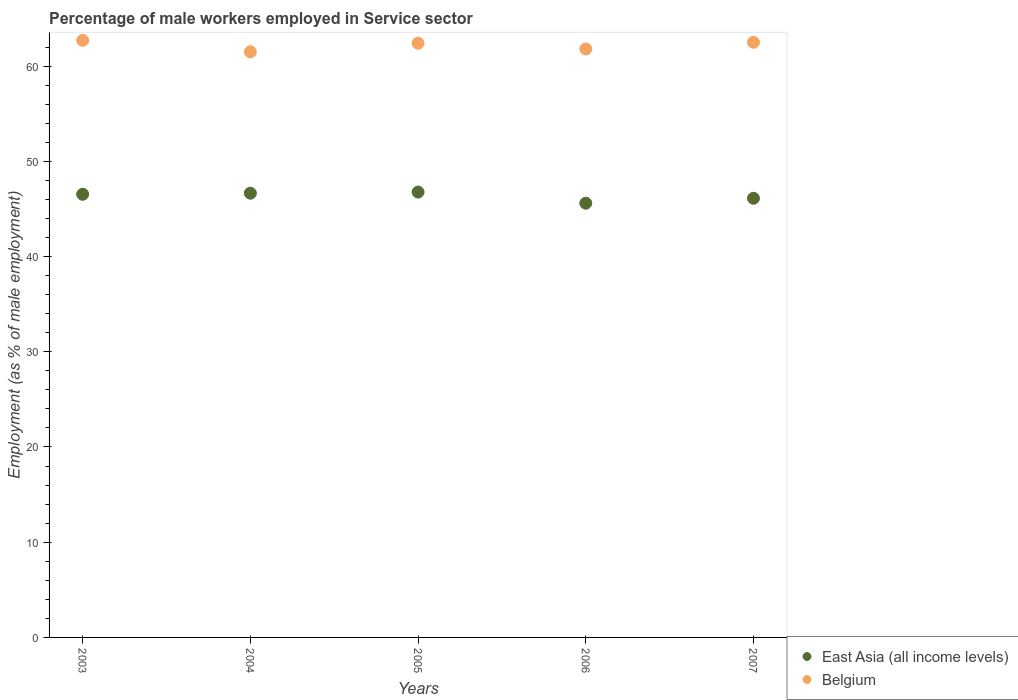Is the number of dotlines equal to the number of legend labels?
Keep it short and to the point. Yes. What is the percentage of male workers employed in Service sector in Belgium in 2004?
Offer a very short reply. 61.5. Across all years, what is the maximum percentage of male workers employed in Service sector in East Asia (all income levels)?
Provide a succinct answer. 46.77. Across all years, what is the minimum percentage of male workers employed in Service sector in East Asia (all income levels)?
Ensure brevity in your answer.  45.6. In which year was the percentage of male workers employed in Service sector in Belgium minimum?
Your answer should be compact. 2004. What is the total percentage of male workers employed in Service sector in Belgium in the graph?
Provide a succinct answer. 310.9. What is the difference between the percentage of male workers employed in Service sector in Belgium in 2003 and that in 2007?
Your response must be concise. 0.2. What is the difference between the percentage of male workers employed in Service sector in Belgium in 2004 and the percentage of male workers employed in Service sector in East Asia (all income levels) in 2005?
Provide a succinct answer. 14.73. What is the average percentage of male workers employed in Service sector in Belgium per year?
Provide a short and direct response. 62.18. In the year 2007, what is the difference between the percentage of male workers employed in Service sector in East Asia (all income levels) and percentage of male workers employed in Service sector in Belgium?
Provide a short and direct response. -16.38. What is the ratio of the percentage of male workers employed in Service sector in Belgium in 2004 to that in 2005?
Give a very brief answer. 0.99. What is the difference between the highest and the second highest percentage of male workers employed in Service sector in Belgium?
Your answer should be compact. 0.2. What is the difference between the highest and the lowest percentage of male workers employed in Service sector in Belgium?
Your response must be concise. 1.2. Is the sum of the percentage of male workers employed in Service sector in East Asia (all income levels) in 2005 and 2006 greater than the maximum percentage of male workers employed in Service sector in Belgium across all years?
Provide a short and direct response. Yes. Is the percentage of male workers employed in Service sector in East Asia (all income levels) strictly greater than the percentage of male workers employed in Service sector in Belgium over the years?
Make the answer very short. No. How many dotlines are there?
Make the answer very short. 2. What is the difference between two consecutive major ticks on the Y-axis?
Offer a terse response. 10. Are the values on the major ticks of Y-axis written in scientific E-notation?
Offer a terse response. No. Does the graph contain grids?
Offer a very short reply. No. Where does the legend appear in the graph?
Your answer should be compact. Bottom right. How many legend labels are there?
Your response must be concise. 2. How are the legend labels stacked?
Provide a succinct answer. Vertical. What is the title of the graph?
Provide a succinct answer. Percentage of male workers employed in Service sector. Does "Trinidad and Tobago" appear as one of the legend labels in the graph?
Provide a succinct answer. No. What is the label or title of the X-axis?
Provide a short and direct response. Years. What is the label or title of the Y-axis?
Give a very brief answer. Employment (as % of male employment). What is the Employment (as % of male employment) in East Asia (all income levels) in 2003?
Your answer should be very brief. 46.54. What is the Employment (as % of male employment) of Belgium in 2003?
Offer a terse response. 62.7. What is the Employment (as % of male employment) in East Asia (all income levels) in 2004?
Give a very brief answer. 46.65. What is the Employment (as % of male employment) of Belgium in 2004?
Provide a short and direct response. 61.5. What is the Employment (as % of male employment) in East Asia (all income levels) in 2005?
Your answer should be very brief. 46.77. What is the Employment (as % of male employment) in Belgium in 2005?
Keep it short and to the point. 62.4. What is the Employment (as % of male employment) in East Asia (all income levels) in 2006?
Provide a succinct answer. 45.6. What is the Employment (as % of male employment) in Belgium in 2006?
Give a very brief answer. 61.8. What is the Employment (as % of male employment) of East Asia (all income levels) in 2007?
Make the answer very short. 46.12. What is the Employment (as % of male employment) in Belgium in 2007?
Provide a succinct answer. 62.5. Across all years, what is the maximum Employment (as % of male employment) in East Asia (all income levels)?
Make the answer very short. 46.77. Across all years, what is the maximum Employment (as % of male employment) in Belgium?
Your answer should be very brief. 62.7. Across all years, what is the minimum Employment (as % of male employment) in East Asia (all income levels)?
Provide a succinct answer. 45.6. Across all years, what is the minimum Employment (as % of male employment) in Belgium?
Keep it short and to the point. 61.5. What is the total Employment (as % of male employment) in East Asia (all income levels) in the graph?
Your response must be concise. 231.68. What is the total Employment (as % of male employment) of Belgium in the graph?
Your answer should be compact. 310.9. What is the difference between the Employment (as % of male employment) of East Asia (all income levels) in 2003 and that in 2004?
Your answer should be very brief. -0.11. What is the difference between the Employment (as % of male employment) in East Asia (all income levels) in 2003 and that in 2005?
Provide a short and direct response. -0.23. What is the difference between the Employment (as % of male employment) in Belgium in 2003 and that in 2005?
Your response must be concise. 0.3. What is the difference between the Employment (as % of male employment) of East Asia (all income levels) in 2003 and that in 2006?
Provide a succinct answer. 0.94. What is the difference between the Employment (as % of male employment) in East Asia (all income levels) in 2003 and that in 2007?
Your response must be concise. 0.42. What is the difference between the Employment (as % of male employment) of East Asia (all income levels) in 2004 and that in 2005?
Ensure brevity in your answer.  -0.12. What is the difference between the Employment (as % of male employment) of East Asia (all income levels) in 2004 and that in 2006?
Give a very brief answer. 1.05. What is the difference between the Employment (as % of male employment) in Belgium in 2004 and that in 2006?
Provide a short and direct response. -0.3. What is the difference between the Employment (as % of male employment) in East Asia (all income levels) in 2004 and that in 2007?
Offer a terse response. 0.53. What is the difference between the Employment (as % of male employment) of Belgium in 2004 and that in 2007?
Provide a succinct answer. -1. What is the difference between the Employment (as % of male employment) in East Asia (all income levels) in 2005 and that in 2006?
Your answer should be compact. 1.17. What is the difference between the Employment (as % of male employment) of Belgium in 2005 and that in 2006?
Give a very brief answer. 0.6. What is the difference between the Employment (as % of male employment) of East Asia (all income levels) in 2005 and that in 2007?
Provide a succinct answer. 0.65. What is the difference between the Employment (as % of male employment) in East Asia (all income levels) in 2006 and that in 2007?
Provide a succinct answer. -0.52. What is the difference between the Employment (as % of male employment) of East Asia (all income levels) in 2003 and the Employment (as % of male employment) of Belgium in 2004?
Give a very brief answer. -14.96. What is the difference between the Employment (as % of male employment) of East Asia (all income levels) in 2003 and the Employment (as % of male employment) of Belgium in 2005?
Provide a short and direct response. -15.86. What is the difference between the Employment (as % of male employment) in East Asia (all income levels) in 2003 and the Employment (as % of male employment) in Belgium in 2006?
Keep it short and to the point. -15.26. What is the difference between the Employment (as % of male employment) in East Asia (all income levels) in 2003 and the Employment (as % of male employment) in Belgium in 2007?
Your answer should be very brief. -15.96. What is the difference between the Employment (as % of male employment) of East Asia (all income levels) in 2004 and the Employment (as % of male employment) of Belgium in 2005?
Offer a terse response. -15.75. What is the difference between the Employment (as % of male employment) in East Asia (all income levels) in 2004 and the Employment (as % of male employment) in Belgium in 2006?
Ensure brevity in your answer.  -15.15. What is the difference between the Employment (as % of male employment) of East Asia (all income levels) in 2004 and the Employment (as % of male employment) of Belgium in 2007?
Your answer should be compact. -15.85. What is the difference between the Employment (as % of male employment) in East Asia (all income levels) in 2005 and the Employment (as % of male employment) in Belgium in 2006?
Make the answer very short. -15.03. What is the difference between the Employment (as % of male employment) in East Asia (all income levels) in 2005 and the Employment (as % of male employment) in Belgium in 2007?
Your answer should be compact. -15.73. What is the difference between the Employment (as % of male employment) of East Asia (all income levels) in 2006 and the Employment (as % of male employment) of Belgium in 2007?
Provide a short and direct response. -16.9. What is the average Employment (as % of male employment) in East Asia (all income levels) per year?
Offer a terse response. 46.34. What is the average Employment (as % of male employment) in Belgium per year?
Your answer should be compact. 62.18. In the year 2003, what is the difference between the Employment (as % of male employment) in East Asia (all income levels) and Employment (as % of male employment) in Belgium?
Make the answer very short. -16.16. In the year 2004, what is the difference between the Employment (as % of male employment) in East Asia (all income levels) and Employment (as % of male employment) in Belgium?
Give a very brief answer. -14.85. In the year 2005, what is the difference between the Employment (as % of male employment) in East Asia (all income levels) and Employment (as % of male employment) in Belgium?
Your answer should be very brief. -15.63. In the year 2006, what is the difference between the Employment (as % of male employment) of East Asia (all income levels) and Employment (as % of male employment) of Belgium?
Provide a short and direct response. -16.2. In the year 2007, what is the difference between the Employment (as % of male employment) of East Asia (all income levels) and Employment (as % of male employment) of Belgium?
Provide a succinct answer. -16.38. What is the ratio of the Employment (as % of male employment) of East Asia (all income levels) in 2003 to that in 2004?
Ensure brevity in your answer.  1. What is the ratio of the Employment (as % of male employment) in Belgium in 2003 to that in 2004?
Your response must be concise. 1.02. What is the ratio of the Employment (as % of male employment) in East Asia (all income levels) in 2003 to that in 2005?
Provide a succinct answer. 1. What is the ratio of the Employment (as % of male employment) of East Asia (all income levels) in 2003 to that in 2006?
Provide a succinct answer. 1.02. What is the ratio of the Employment (as % of male employment) in Belgium in 2003 to that in 2006?
Your response must be concise. 1.01. What is the ratio of the Employment (as % of male employment) of East Asia (all income levels) in 2003 to that in 2007?
Make the answer very short. 1.01. What is the ratio of the Employment (as % of male employment) in Belgium in 2004 to that in 2005?
Your response must be concise. 0.99. What is the ratio of the Employment (as % of male employment) of Belgium in 2004 to that in 2006?
Your response must be concise. 1. What is the ratio of the Employment (as % of male employment) of East Asia (all income levels) in 2004 to that in 2007?
Your response must be concise. 1.01. What is the ratio of the Employment (as % of male employment) in Belgium in 2004 to that in 2007?
Make the answer very short. 0.98. What is the ratio of the Employment (as % of male employment) of East Asia (all income levels) in 2005 to that in 2006?
Give a very brief answer. 1.03. What is the ratio of the Employment (as % of male employment) of Belgium in 2005 to that in 2006?
Your answer should be very brief. 1.01. What is the ratio of the Employment (as % of male employment) of East Asia (all income levels) in 2005 to that in 2007?
Offer a very short reply. 1.01. What is the ratio of the Employment (as % of male employment) of East Asia (all income levels) in 2006 to that in 2007?
Keep it short and to the point. 0.99. What is the ratio of the Employment (as % of male employment) in Belgium in 2006 to that in 2007?
Your answer should be compact. 0.99. What is the difference between the highest and the second highest Employment (as % of male employment) in East Asia (all income levels)?
Give a very brief answer. 0.12. What is the difference between the highest and the lowest Employment (as % of male employment) in East Asia (all income levels)?
Provide a short and direct response. 1.17. 